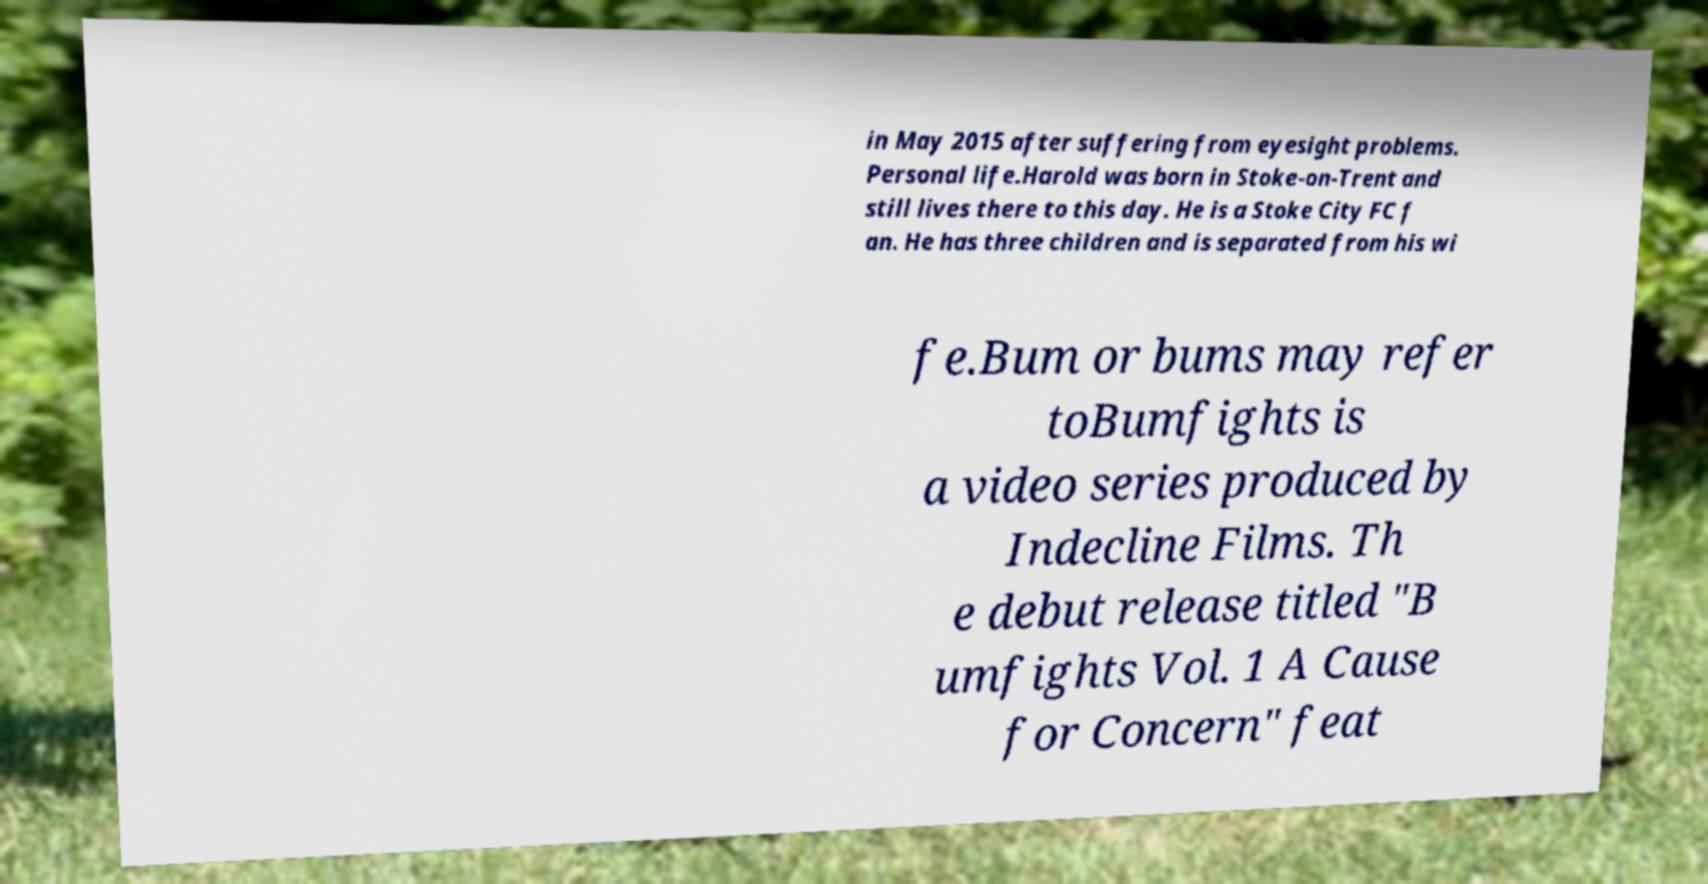Could you assist in decoding the text presented in this image and type it out clearly? in May 2015 after suffering from eyesight problems. Personal life.Harold was born in Stoke-on-Trent and still lives there to this day. He is a Stoke City FC f an. He has three children and is separated from his wi fe.Bum or bums may refer toBumfights is a video series produced by Indecline Films. Th e debut release titled "B umfights Vol. 1 A Cause for Concern" feat 